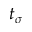<formula> <loc_0><loc_0><loc_500><loc_500>t _ { \sigma }</formula> 